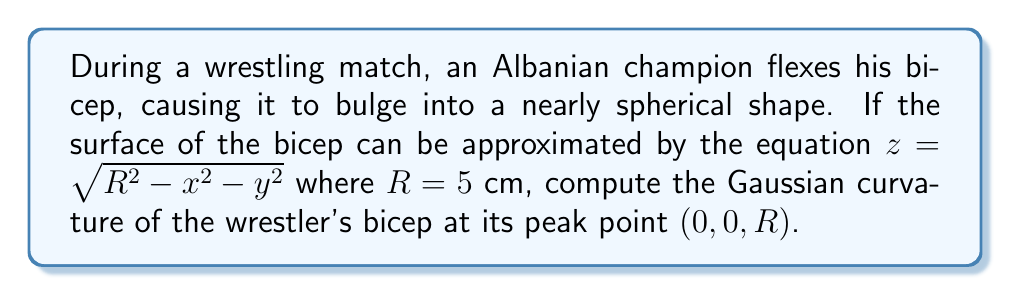Can you answer this question? To compute the Gaussian curvature, we'll follow these steps:

1) The Gaussian curvature $K$ is given by $K = \kappa_1 \kappa_2$, where $\kappa_1$ and $\kappa_2$ are the principal curvatures.

2) For a surface of the form $z = f(x,y)$, the Gaussian curvature is given by:

   $$K = \frac{f_{xx}f_{yy} - f_{xy}^2}{(1 + f_x^2 + f_y^2)^2}$$

   where subscripts denote partial derivatives.

3) Let's calculate the partial derivatives:

   $f_x = \frac{-x}{\sqrt{R^2 - x^2 - y^2}}$
   $f_y = \frac{-y}{\sqrt{R^2 - x^2 - y^2}}$
   $f_{xx} = \frac{-R^2 + y^2}{(R^2 - x^2 - y^2)^{3/2}}$
   $f_{yy} = \frac{-R^2 + x^2}{(R^2 - x^2 - y^2)^{3/2}}$
   $f_{xy} = \frac{xy}{(R^2 - x^2 - y^2)^{3/2}}$

4) At the peak point $(0, 0, R)$, these simplify to:

   $f_x = f_y = 0$
   $f_{xx} = f_{yy} = -\frac{1}{R}$
   $f_{xy} = 0$

5) Substituting into the Gaussian curvature formula:

   $$K = \frac{(-\frac{1}{R})(-\frac{1}{R}) - 0^2}{(1 + 0^2 + 0^2)^2} = \frac{1}{R^2}$$

6) Finally, substituting $R = 5$ cm:

   $$K = \frac{1}{5^2} = \frac{1}{25} \text{ cm}^{-2}$$
Answer: $\frac{1}{25} \text{ cm}^{-2}$ 